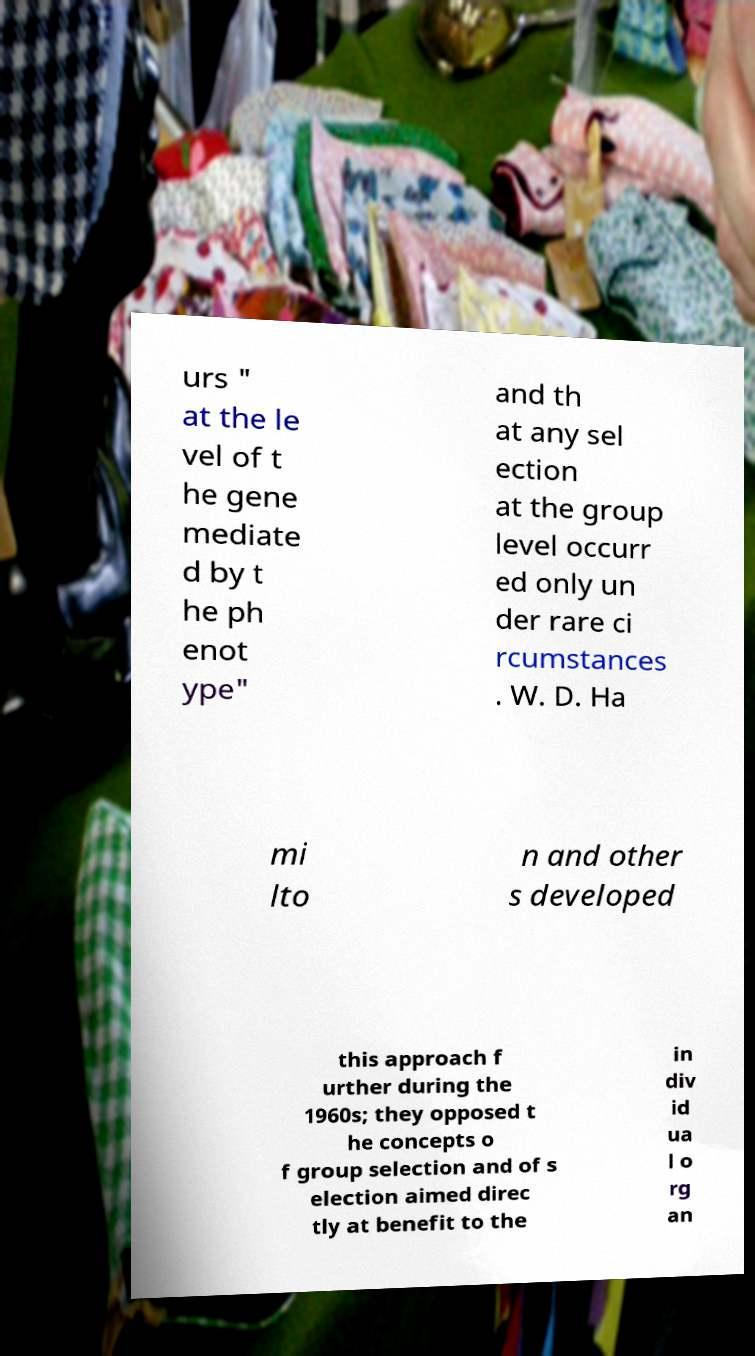For documentation purposes, I need the text within this image transcribed. Could you provide that? urs " at the le vel of t he gene mediate d by t he ph enot ype" and th at any sel ection at the group level occurr ed only un der rare ci rcumstances . W. D. Ha mi lto n and other s developed this approach f urther during the 1960s; they opposed t he concepts o f group selection and of s election aimed direc tly at benefit to the in div id ua l o rg an 